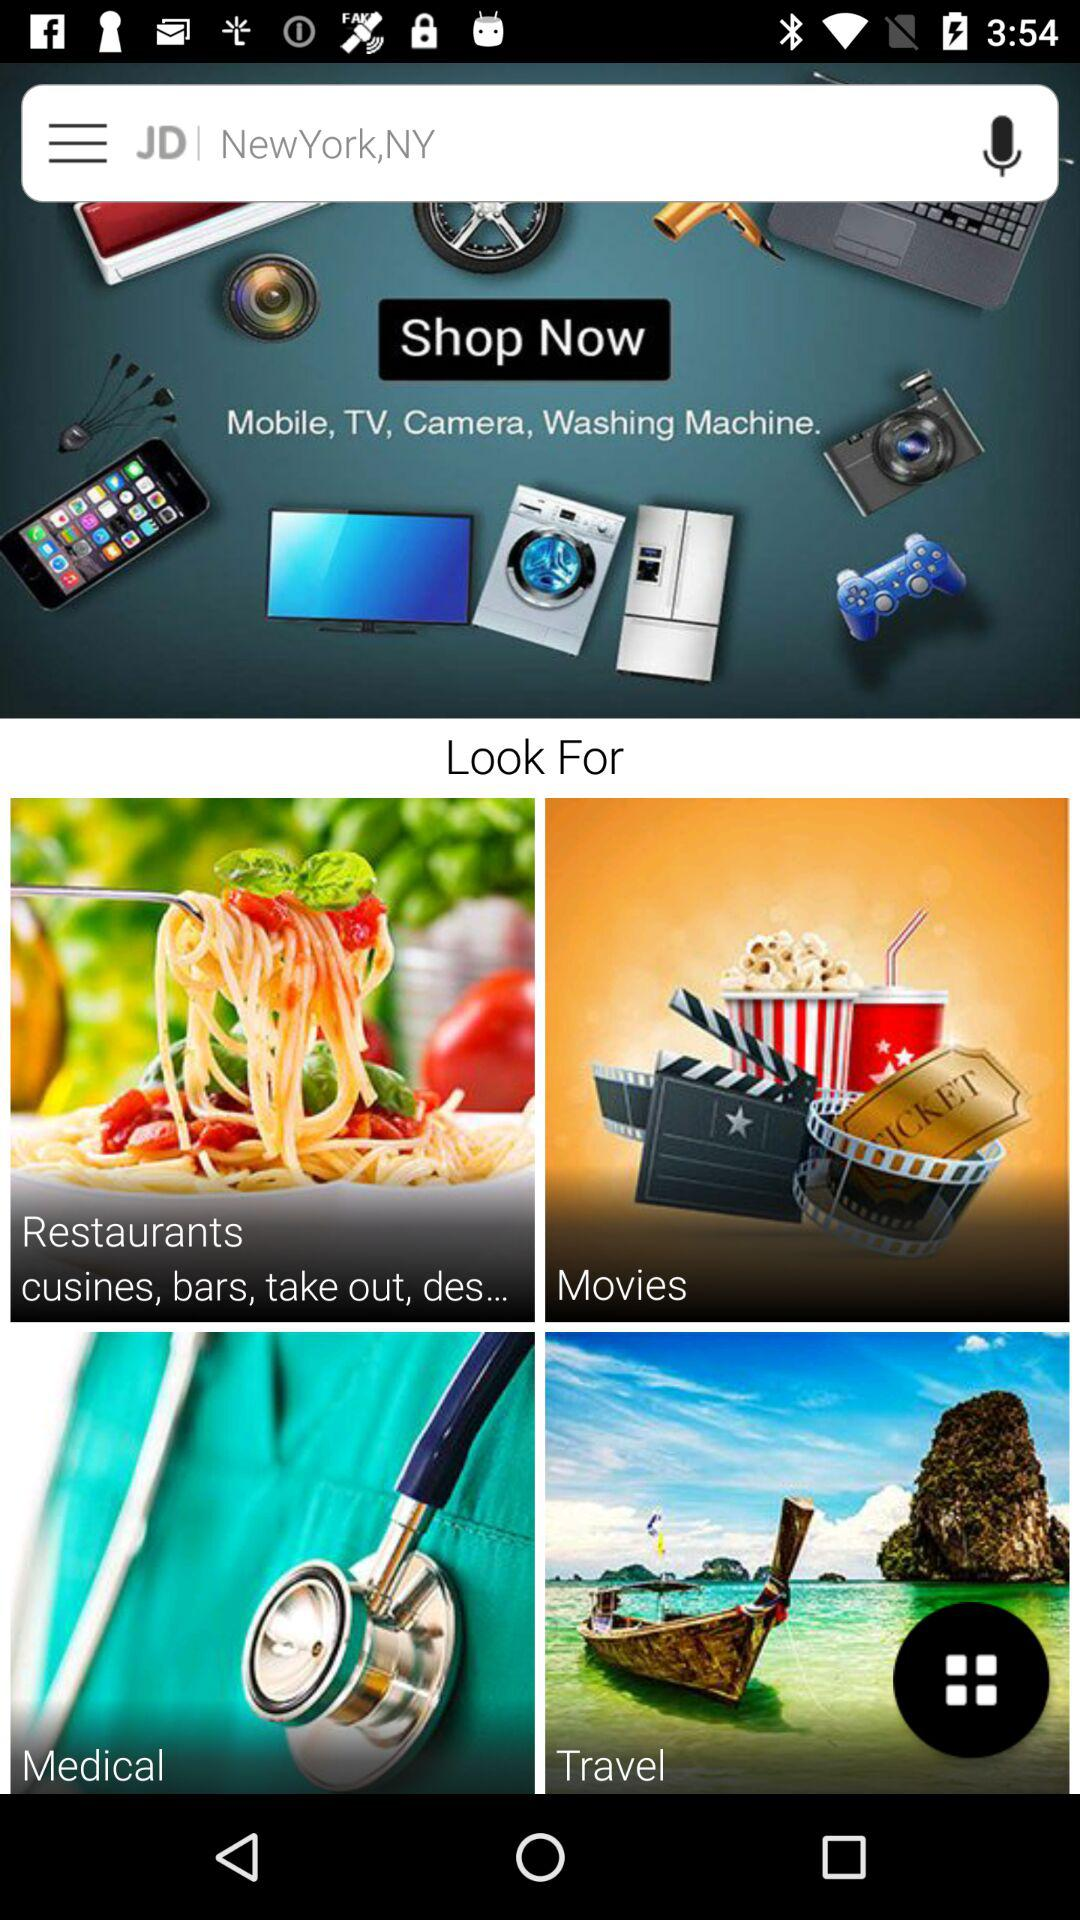What is the name of the application? The name of the application is "JD". 